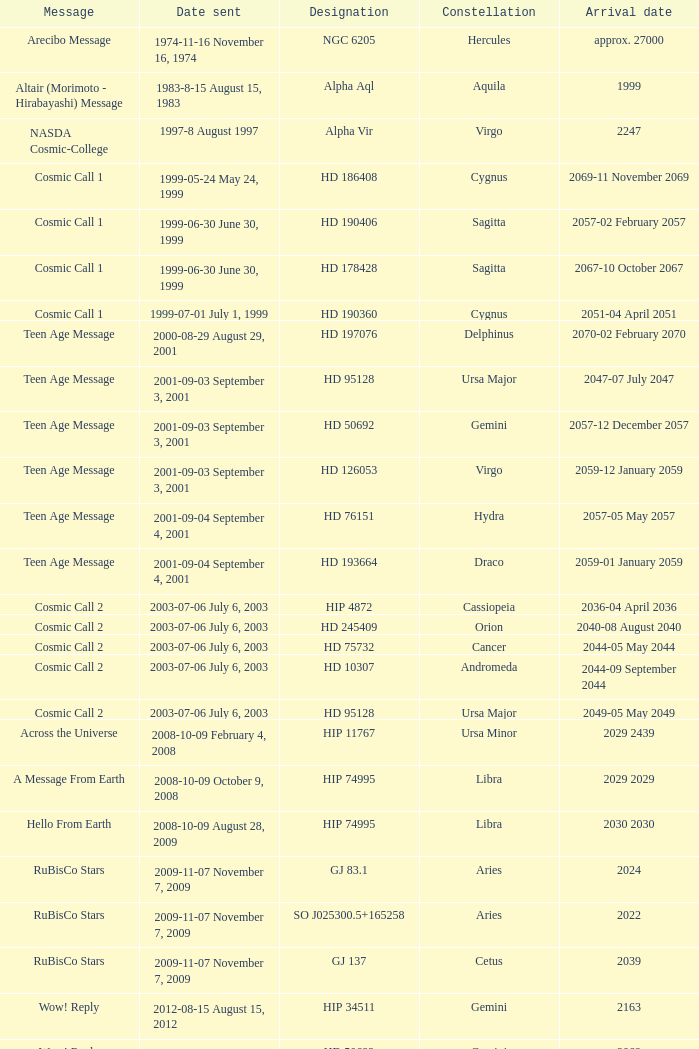In which part of the sky can hip 4872 be found? Cassiopeia. 